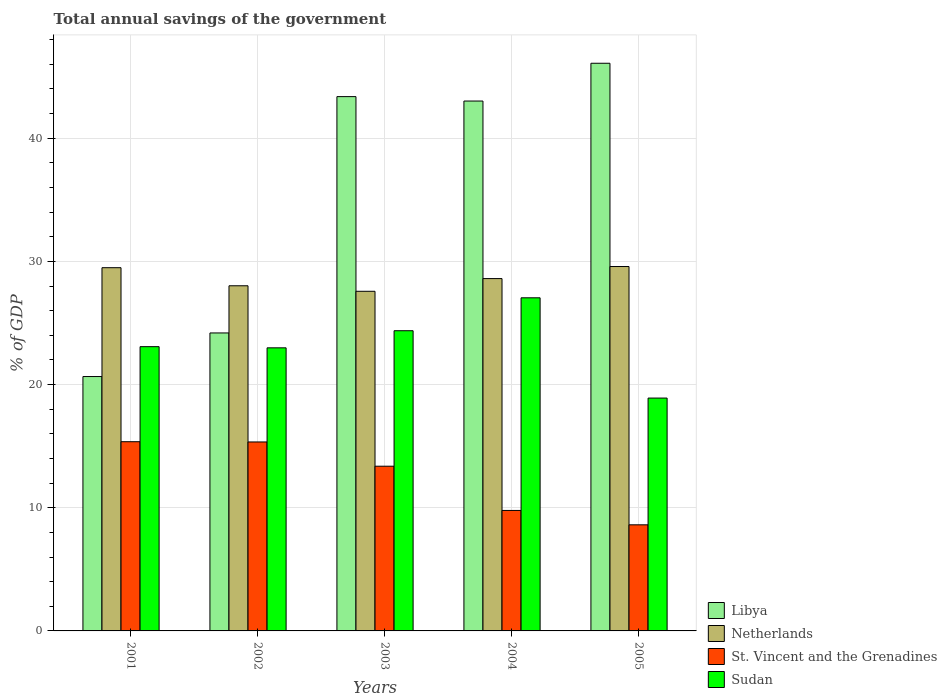How many different coloured bars are there?
Your answer should be compact. 4. Are the number of bars per tick equal to the number of legend labels?
Offer a terse response. Yes. Are the number of bars on each tick of the X-axis equal?
Offer a terse response. Yes. How many bars are there on the 1st tick from the left?
Make the answer very short. 4. What is the label of the 3rd group of bars from the left?
Your answer should be compact. 2003. In how many cases, is the number of bars for a given year not equal to the number of legend labels?
Ensure brevity in your answer.  0. What is the total annual savings of the government in Libya in 2005?
Ensure brevity in your answer.  46.09. Across all years, what is the maximum total annual savings of the government in St. Vincent and the Grenadines?
Your answer should be compact. 15.36. Across all years, what is the minimum total annual savings of the government in Netherlands?
Make the answer very short. 27.58. In which year was the total annual savings of the government in St. Vincent and the Grenadines maximum?
Your answer should be very brief. 2001. What is the total total annual savings of the government in Libya in the graph?
Your answer should be compact. 177.34. What is the difference between the total annual savings of the government in Netherlands in 2002 and that in 2003?
Provide a succinct answer. 0.45. What is the difference between the total annual savings of the government in Libya in 2003 and the total annual savings of the government in Sudan in 2001?
Your response must be concise. 20.3. What is the average total annual savings of the government in Libya per year?
Offer a terse response. 35.47. In the year 2002, what is the difference between the total annual savings of the government in St. Vincent and the Grenadines and total annual savings of the government in Netherlands?
Give a very brief answer. -12.68. What is the ratio of the total annual savings of the government in St. Vincent and the Grenadines in 2001 to that in 2002?
Provide a succinct answer. 1. Is the difference between the total annual savings of the government in St. Vincent and the Grenadines in 2002 and 2005 greater than the difference between the total annual savings of the government in Netherlands in 2002 and 2005?
Your answer should be very brief. Yes. What is the difference between the highest and the second highest total annual savings of the government in Sudan?
Make the answer very short. 2.67. What is the difference between the highest and the lowest total annual savings of the government in Libya?
Make the answer very short. 25.44. In how many years, is the total annual savings of the government in St. Vincent and the Grenadines greater than the average total annual savings of the government in St. Vincent and the Grenadines taken over all years?
Your answer should be very brief. 3. Is the sum of the total annual savings of the government in St. Vincent and the Grenadines in 2002 and 2005 greater than the maximum total annual savings of the government in Libya across all years?
Make the answer very short. No. What does the 2nd bar from the left in 2005 represents?
Your answer should be compact. Netherlands. What does the 1st bar from the right in 2002 represents?
Make the answer very short. Sudan. How many bars are there?
Your answer should be compact. 20. Where does the legend appear in the graph?
Ensure brevity in your answer.  Bottom right. How are the legend labels stacked?
Ensure brevity in your answer.  Vertical. What is the title of the graph?
Your response must be concise. Total annual savings of the government. What is the label or title of the Y-axis?
Your response must be concise. % of GDP. What is the % of GDP in Libya in 2001?
Your answer should be compact. 20.65. What is the % of GDP in Netherlands in 2001?
Give a very brief answer. 29.49. What is the % of GDP in St. Vincent and the Grenadines in 2001?
Provide a succinct answer. 15.36. What is the % of GDP of Sudan in 2001?
Your response must be concise. 23.08. What is the % of GDP of Libya in 2002?
Give a very brief answer. 24.19. What is the % of GDP in Netherlands in 2002?
Give a very brief answer. 28.02. What is the % of GDP of St. Vincent and the Grenadines in 2002?
Offer a terse response. 15.34. What is the % of GDP in Sudan in 2002?
Give a very brief answer. 22.98. What is the % of GDP of Libya in 2003?
Provide a succinct answer. 43.38. What is the % of GDP of Netherlands in 2003?
Provide a succinct answer. 27.58. What is the % of GDP of St. Vincent and the Grenadines in 2003?
Provide a succinct answer. 13.37. What is the % of GDP in Sudan in 2003?
Ensure brevity in your answer.  24.37. What is the % of GDP of Libya in 2004?
Provide a short and direct response. 43.02. What is the % of GDP in Netherlands in 2004?
Your response must be concise. 28.61. What is the % of GDP in St. Vincent and the Grenadines in 2004?
Offer a very short reply. 9.78. What is the % of GDP in Sudan in 2004?
Give a very brief answer. 27.05. What is the % of GDP in Libya in 2005?
Give a very brief answer. 46.09. What is the % of GDP in Netherlands in 2005?
Keep it short and to the point. 29.59. What is the % of GDP in St. Vincent and the Grenadines in 2005?
Your answer should be very brief. 8.61. What is the % of GDP of Sudan in 2005?
Give a very brief answer. 18.9. Across all years, what is the maximum % of GDP in Libya?
Keep it short and to the point. 46.09. Across all years, what is the maximum % of GDP in Netherlands?
Offer a very short reply. 29.59. Across all years, what is the maximum % of GDP of St. Vincent and the Grenadines?
Provide a short and direct response. 15.36. Across all years, what is the maximum % of GDP of Sudan?
Make the answer very short. 27.05. Across all years, what is the minimum % of GDP of Libya?
Your response must be concise. 20.65. Across all years, what is the minimum % of GDP of Netherlands?
Provide a short and direct response. 27.58. Across all years, what is the minimum % of GDP in St. Vincent and the Grenadines?
Offer a very short reply. 8.61. Across all years, what is the minimum % of GDP in Sudan?
Your response must be concise. 18.9. What is the total % of GDP of Libya in the graph?
Keep it short and to the point. 177.34. What is the total % of GDP in Netherlands in the graph?
Offer a very short reply. 143.28. What is the total % of GDP in St. Vincent and the Grenadines in the graph?
Offer a very short reply. 62.47. What is the total % of GDP of Sudan in the graph?
Offer a terse response. 116.39. What is the difference between the % of GDP in Libya in 2001 and that in 2002?
Provide a succinct answer. -3.54. What is the difference between the % of GDP in Netherlands in 2001 and that in 2002?
Your response must be concise. 1.47. What is the difference between the % of GDP of St. Vincent and the Grenadines in 2001 and that in 2002?
Make the answer very short. 0.02. What is the difference between the % of GDP of Sudan in 2001 and that in 2002?
Your answer should be very brief. 0.09. What is the difference between the % of GDP in Libya in 2001 and that in 2003?
Give a very brief answer. -22.73. What is the difference between the % of GDP in Netherlands in 2001 and that in 2003?
Your answer should be very brief. 1.92. What is the difference between the % of GDP of St. Vincent and the Grenadines in 2001 and that in 2003?
Provide a succinct answer. 1.99. What is the difference between the % of GDP in Sudan in 2001 and that in 2003?
Your answer should be very brief. -1.29. What is the difference between the % of GDP in Libya in 2001 and that in 2004?
Offer a terse response. -22.37. What is the difference between the % of GDP of Netherlands in 2001 and that in 2004?
Your answer should be compact. 0.88. What is the difference between the % of GDP of St. Vincent and the Grenadines in 2001 and that in 2004?
Make the answer very short. 5.58. What is the difference between the % of GDP of Sudan in 2001 and that in 2004?
Provide a short and direct response. -3.97. What is the difference between the % of GDP of Libya in 2001 and that in 2005?
Your answer should be compact. -25.44. What is the difference between the % of GDP in Netherlands in 2001 and that in 2005?
Your response must be concise. -0.1. What is the difference between the % of GDP in St. Vincent and the Grenadines in 2001 and that in 2005?
Your answer should be compact. 6.75. What is the difference between the % of GDP in Sudan in 2001 and that in 2005?
Provide a succinct answer. 4.17. What is the difference between the % of GDP of Libya in 2002 and that in 2003?
Your answer should be very brief. -19.19. What is the difference between the % of GDP of Netherlands in 2002 and that in 2003?
Offer a very short reply. 0.45. What is the difference between the % of GDP of St. Vincent and the Grenadines in 2002 and that in 2003?
Your answer should be compact. 1.97. What is the difference between the % of GDP in Sudan in 2002 and that in 2003?
Your answer should be very brief. -1.39. What is the difference between the % of GDP in Libya in 2002 and that in 2004?
Keep it short and to the point. -18.83. What is the difference between the % of GDP of Netherlands in 2002 and that in 2004?
Give a very brief answer. -0.58. What is the difference between the % of GDP in St. Vincent and the Grenadines in 2002 and that in 2004?
Provide a short and direct response. 5.56. What is the difference between the % of GDP in Sudan in 2002 and that in 2004?
Offer a terse response. -4.06. What is the difference between the % of GDP of Libya in 2002 and that in 2005?
Give a very brief answer. -21.9. What is the difference between the % of GDP of Netherlands in 2002 and that in 2005?
Offer a terse response. -1.56. What is the difference between the % of GDP of St. Vincent and the Grenadines in 2002 and that in 2005?
Ensure brevity in your answer.  6.73. What is the difference between the % of GDP of Sudan in 2002 and that in 2005?
Your answer should be compact. 4.08. What is the difference between the % of GDP of Libya in 2003 and that in 2004?
Provide a succinct answer. 0.36. What is the difference between the % of GDP of Netherlands in 2003 and that in 2004?
Ensure brevity in your answer.  -1.03. What is the difference between the % of GDP in St. Vincent and the Grenadines in 2003 and that in 2004?
Provide a succinct answer. 3.59. What is the difference between the % of GDP in Sudan in 2003 and that in 2004?
Keep it short and to the point. -2.67. What is the difference between the % of GDP of Libya in 2003 and that in 2005?
Give a very brief answer. -2.71. What is the difference between the % of GDP of Netherlands in 2003 and that in 2005?
Your response must be concise. -2.01. What is the difference between the % of GDP in St. Vincent and the Grenadines in 2003 and that in 2005?
Provide a succinct answer. 4.76. What is the difference between the % of GDP in Sudan in 2003 and that in 2005?
Make the answer very short. 5.47. What is the difference between the % of GDP of Libya in 2004 and that in 2005?
Your answer should be very brief. -3.07. What is the difference between the % of GDP in Netherlands in 2004 and that in 2005?
Provide a short and direct response. -0.98. What is the difference between the % of GDP of St. Vincent and the Grenadines in 2004 and that in 2005?
Provide a short and direct response. 1.17. What is the difference between the % of GDP in Sudan in 2004 and that in 2005?
Your answer should be compact. 8.14. What is the difference between the % of GDP of Libya in 2001 and the % of GDP of Netherlands in 2002?
Your answer should be compact. -7.37. What is the difference between the % of GDP in Libya in 2001 and the % of GDP in St. Vincent and the Grenadines in 2002?
Make the answer very short. 5.31. What is the difference between the % of GDP in Libya in 2001 and the % of GDP in Sudan in 2002?
Provide a short and direct response. -2.33. What is the difference between the % of GDP in Netherlands in 2001 and the % of GDP in St. Vincent and the Grenadines in 2002?
Offer a terse response. 14.15. What is the difference between the % of GDP of Netherlands in 2001 and the % of GDP of Sudan in 2002?
Make the answer very short. 6.51. What is the difference between the % of GDP in St. Vincent and the Grenadines in 2001 and the % of GDP in Sudan in 2002?
Offer a very short reply. -7.62. What is the difference between the % of GDP in Libya in 2001 and the % of GDP in Netherlands in 2003?
Your answer should be compact. -6.92. What is the difference between the % of GDP in Libya in 2001 and the % of GDP in St. Vincent and the Grenadines in 2003?
Make the answer very short. 7.28. What is the difference between the % of GDP in Libya in 2001 and the % of GDP in Sudan in 2003?
Provide a succinct answer. -3.72. What is the difference between the % of GDP of Netherlands in 2001 and the % of GDP of St. Vincent and the Grenadines in 2003?
Keep it short and to the point. 16.12. What is the difference between the % of GDP in Netherlands in 2001 and the % of GDP in Sudan in 2003?
Make the answer very short. 5.12. What is the difference between the % of GDP of St. Vincent and the Grenadines in 2001 and the % of GDP of Sudan in 2003?
Offer a terse response. -9.01. What is the difference between the % of GDP of Libya in 2001 and the % of GDP of Netherlands in 2004?
Ensure brevity in your answer.  -7.95. What is the difference between the % of GDP of Libya in 2001 and the % of GDP of St. Vincent and the Grenadines in 2004?
Keep it short and to the point. 10.87. What is the difference between the % of GDP of Libya in 2001 and the % of GDP of Sudan in 2004?
Your answer should be compact. -6.39. What is the difference between the % of GDP of Netherlands in 2001 and the % of GDP of St. Vincent and the Grenadines in 2004?
Provide a short and direct response. 19.71. What is the difference between the % of GDP of Netherlands in 2001 and the % of GDP of Sudan in 2004?
Provide a short and direct response. 2.44. What is the difference between the % of GDP of St. Vincent and the Grenadines in 2001 and the % of GDP of Sudan in 2004?
Offer a terse response. -11.68. What is the difference between the % of GDP of Libya in 2001 and the % of GDP of Netherlands in 2005?
Provide a short and direct response. -8.93. What is the difference between the % of GDP of Libya in 2001 and the % of GDP of St. Vincent and the Grenadines in 2005?
Your response must be concise. 12.04. What is the difference between the % of GDP of Libya in 2001 and the % of GDP of Sudan in 2005?
Keep it short and to the point. 1.75. What is the difference between the % of GDP in Netherlands in 2001 and the % of GDP in St. Vincent and the Grenadines in 2005?
Your answer should be compact. 20.88. What is the difference between the % of GDP of Netherlands in 2001 and the % of GDP of Sudan in 2005?
Ensure brevity in your answer.  10.59. What is the difference between the % of GDP in St. Vincent and the Grenadines in 2001 and the % of GDP in Sudan in 2005?
Your answer should be very brief. -3.54. What is the difference between the % of GDP in Libya in 2002 and the % of GDP in Netherlands in 2003?
Make the answer very short. -3.38. What is the difference between the % of GDP of Libya in 2002 and the % of GDP of St. Vincent and the Grenadines in 2003?
Provide a short and direct response. 10.82. What is the difference between the % of GDP in Libya in 2002 and the % of GDP in Sudan in 2003?
Your answer should be very brief. -0.18. What is the difference between the % of GDP of Netherlands in 2002 and the % of GDP of St. Vincent and the Grenadines in 2003?
Provide a short and direct response. 14.65. What is the difference between the % of GDP of Netherlands in 2002 and the % of GDP of Sudan in 2003?
Offer a very short reply. 3.65. What is the difference between the % of GDP in St. Vincent and the Grenadines in 2002 and the % of GDP in Sudan in 2003?
Your answer should be very brief. -9.03. What is the difference between the % of GDP in Libya in 2002 and the % of GDP in Netherlands in 2004?
Your answer should be compact. -4.41. What is the difference between the % of GDP in Libya in 2002 and the % of GDP in St. Vincent and the Grenadines in 2004?
Your answer should be compact. 14.41. What is the difference between the % of GDP in Libya in 2002 and the % of GDP in Sudan in 2004?
Your answer should be very brief. -2.85. What is the difference between the % of GDP in Netherlands in 2002 and the % of GDP in St. Vincent and the Grenadines in 2004?
Your response must be concise. 18.24. What is the difference between the % of GDP in Netherlands in 2002 and the % of GDP in Sudan in 2004?
Ensure brevity in your answer.  0.98. What is the difference between the % of GDP in St. Vincent and the Grenadines in 2002 and the % of GDP in Sudan in 2004?
Your answer should be compact. -11.7. What is the difference between the % of GDP in Libya in 2002 and the % of GDP in Netherlands in 2005?
Keep it short and to the point. -5.39. What is the difference between the % of GDP in Libya in 2002 and the % of GDP in St. Vincent and the Grenadines in 2005?
Ensure brevity in your answer.  15.58. What is the difference between the % of GDP of Libya in 2002 and the % of GDP of Sudan in 2005?
Give a very brief answer. 5.29. What is the difference between the % of GDP in Netherlands in 2002 and the % of GDP in St. Vincent and the Grenadines in 2005?
Ensure brevity in your answer.  19.41. What is the difference between the % of GDP of Netherlands in 2002 and the % of GDP of Sudan in 2005?
Provide a succinct answer. 9.12. What is the difference between the % of GDP in St. Vincent and the Grenadines in 2002 and the % of GDP in Sudan in 2005?
Provide a short and direct response. -3.56. What is the difference between the % of GDP in Libya in 2003 and the % of GDP in Netherlands in 2004?
Your answer should be compact. 14.77. What is the difference between the % of GDP in Libya in 2003 and the % of GDP in St. Vincent and the Grenadines in 2004?
Keep it short and to the point. 33.6. What is the difference between the % of GDP in Libya in 2003 and the % of GDP in Sudan in 2004?
Give a very brief answer. 16.33. What is the difference between the % of GDP of Netherlands in 2003 and the % of GDP of St. Vincent and the Grenadines in 2004?
Offer a very short reply. 17.79. What is the difference between the % of GDP of Netherlands in 2003 and the % of GDP of Sudan in 2004?
Provide a succinct answer. 0.53. What is the difference between the % of GDP in St. Vincent and the Grenadines in 2003 and the % of GDP in Sudan in 2004?
Your answer should be very brief. -13.67. What is the difference between the % of GDP in Libya in 2003 and the % of GDP in Netherlands in 2005?
Offer a terse response. 13.79. What is the difference between the % of GDP in Libya in 2003 and the % of GDP in St. Vincent and the Grenadines in 2005?
Your answer should be very brief. 34.77. What is the difference between the % of GDP of Libya in 2003 and the % of GDP of Sudan in 2005?
Keep it short and to the point. 24.48. What is the difference between the % of GDP in Netherlands in 2003 and the % of GDP in St. Vincent and the Grenadines in 2005?
Offer a terse response. 18.96. What is the difference between the % of GDP of Netherlands in 2003 and the % of GDP of Sudan in 2005?
Offer a terse response. 8.67. What is the difference between the % of GDP in St. Vincent and the Grenadines in 2003 and the % of GDP in Sudan in 2005?
Keep it short and to the point. -5.53. What is the difference between the % of GDP of Libya in 2004 and the % of GDP of Netherlands in 2005?
Offer a very short reply. 13.44. What is the difference between the % of GDP in Libya in 2004 and the % of GDP in St. Vincent and the Grenadines in 2005?
Offer a terse response. 34.41. What is the difference between the % of GDP in Libya in 2004 and the % of GDP in Sudan in 2005?
Keep it short and to the point. 24.12. What is the difference between the % of GDP of Netherlands in 2004 and the % of GDP of St. Vincent and the Grenadines in 2005?
Your response must be concise. 19.99. What is the difference between the % of GDP in Netherlands in 2004 and the % of GDP in Sudan in 2005?
Offer a very short reply. 9.7. What is the difference between the % of GDP of St. Vincent and the Grenadines in 2004 and the % of GDP of Sudan in 2005?
Keep it short and to the point. -9.12. What is the average % of GDP of Libya per year?
Offer a terse response. 35.47. What is the average % of GDP of Netherlands per year?
Offer a terse response. 28.66. What is the average % of GDP of St. Vincent and the Grenadines per year?
Your answer should be compact. 12.49. What is the average % of GDP of Sudan per year?
Your response must be concise. 23.28. In the year 2001, what is the difference between the % of GDP in Libya and % of GDP in Netherlands?
Your answer should be very brief. -8.84. In the year 2001, what is the difference between the % of GDP in Libya and % of GDP in St. Vincent and the Grenadines?
Make the answer very short. 5.29. In the year 2001, what is the difference between the % of GDP of Libya and % of GDP of Sudan?
Offer a terse response. -2.42. In the year 2001, what is the difference between the % of GDP in Netherlands and % of GDP in St. Vincent and the Grenadines?
Keep it short and to the point. 14.13. In the year 2001, what is the difference between the % of GDP in Netherlands and % of GDP in Sudan?
Your answer should be very brief. 6.41. In the year 2001, what is the difference between the % of GDP in St. Vincent and the Grenadines and % of GDP in Sudan?
Provide a short and direct response. -7.72. In the year 2002, what is the difference between the % of GDP of Libya and % of GDP of Netherlands?
Offer a terse response. -3.83. In the year 2002, what is the difference between the % of GDP of Libya and % of GDP of St. Vincent and the Grenadines?
Your answer should be very brief. 8.85. In the year 2002, what is the difference between the % of GDP of Libya and % of GDP of Sudan?
Your answer should be very brief. 1.21. In the year 2002, what is the difference between the % of GDP of Netherlands and % of GDP of St. Vincent and the Grenadines?
Keep it short and to the point. 12.68. In the year 2002, what is the difference between the % of GDP in Netherlands and % of GDP in Sudan?
Keep it short and to the point. 5.04. In the year 2002, what is the difference between the % of GDP in St. Vincent and the Grenadines and % of GDP in Sudan?
Your answer should be very brief. -7.64. In the year 2003, what is the difference between the % of GDP of Libya and % of GDP of Netherlands?
Provide a short and direct response. 15.81. In the year 2003, what is the difference between the % of GDP of Libya and % of GDP of St. Vincent and the Grenadines?
Provide a short and direct response. 30.01. In the year 2003, what is the difference between the % of GDP of Libya and % of GDP of Sudan?
Offer a very short reply. 19.01. In the year 2003, what is the difference between the % of GDP of Netherlands and % of GDP of St. Vincent and the Grenadines?
Ensure brevity in your answer.  14.2. In the year 2003, what is the difference between the % of GDP of Netherlands and % of GDP of Sudan?
Provide a short and direct response. 3.2. In the year 2003, what is the difference between the % of GDP of St. Vincent and the Grenadines and % of GDP of Sudan?
Provide a succinct answer. -11. In the year 2004, what is the difference between the % of GDP of Libya and % of GDP of Netherlands?
Offer a terse response. 14.42. In the year 2004, what is the difference between the % of GDP in Libya and % of GDP in St. Vincent and the Grenadines?
Give a very brief answer. 33.24. In the year 2004, what is the difference between the % of GDP of Libya and % of GDP of Sudan?
Your answer should be very brief. 15.98. In the year 2004, what is the difference between the % of GDP in Netherlands and % of GDP in St. Vincent and the Grenadines?
Your answer should be compact. 18.82. In the year 2004, what is the difference between the % of GDP in Netherlands and % of GDP in Sudan?
Offer a terse response. 1.56. In the year 2004, what is the difference between the % of GDP in St. Vincent and the Grenadines and % of GDP in Sudan?
Provide a short and direct response. -17.26. In the year 2005, what is the difference between the % of GDP of Libya and % of GDP of Netherlands?
Offer a terse response. 16.5. In the year 2005, what is the difference between the % of GDP in Libya and % of GDP in St. Vincent and the Grenadines?
Your answer should be very brief. 37.47. In the year 2005, what is the difference between the % of GDP of Libya and % of GDP of Sudan?
Your answer should be compact. 27.18. In the year 2005, what is the difference between the % of GDP in Netherlands and % of GDP in St. Vincent and the Grenadines?
Provide a succinct answer. 20.97. In the year 2005, what is the difference between the % of GDP in Netherlands and % of GDP in Sudan?
Give a very brief answer. 10.68. In the year 2005, what is the difference between the % of GDP in St. Vincent and the Grenadines and % of GDP in Sudan?
Ensure brevity in your answer.  -10.29. What is the ratio of the % of GDP in Libya in 2001 to that in 2002?
Make the answer very short. 0.85. What is the ratio of the % of GDP of Netherlands in 2001 to that in 2002?
Your answer should be compact. 1.05. What is the ratio of the % of GDP of St. Vincent and the Grenadines in 2001 to that in 2002?
Provide a short and direct response. 1. What is the ratio of the % of GDP in Libya in 2001 to that in 2003?
Make the answer very short. 0.48. What is the ratio of the % of GDP of Netherlands in 2001 to that in 2003?
Provide a succinct answer. 1.07. What is the ratio of the % of GDP in St. Vincent and the Grenadines in 2001 to that in 2003?
Offer a very short reply. 1.15. What is the ratio of the % of GDP of Sudan in 2001 to that in 2003?
Your response must be concise. 0.95. What is the ratio of the % of GDP in Libya in 2001 to that in 2004?
Ensure brevity in your answer.  0.48. What is the ratio of the % of GDP of Netherlands in 2001 to that in 2004?
Provide a short and direct response. 1.03. What is the ratio of the % of GDP of St. Vincent and the Grenadines in 2001 to that in 2004?
Make the answer very short. 1.57. What is the ratio of the % of GDP in Sudan in 2001 to that in 2004?
Give a very brief answer. 0.85. What is the ratio of the % of GDP in Libya in 2001 to that in 2005?
Make the answer very short. 0.45. What is the ratio of the % of GDP in St. Vincent and the Grenadines in 2001 to that in 2005?
Your answer should be very brief. 1.78. What is the ratio of the % of GDP of Sudan in 2001 to that in 2005?
Offer a very short reply. 1.22. What is the ratio of the % of GDP in Libya in 2002 to that in 2003?
Offer a terse response. 0.56. What is the ratio of the % of GDP in Netherlands in 2002 to that in 2003?
Offer a terse response. 1.02. What is the ratio of the % of GDP of St. Vincent and the Grenadines in 2002 to that in 2003?
Offer a terse response. 1.15. What is the ratio of the % of GDP of Sudan in 2002 to that in 2003?
Give a very brief answer. 0.94. What is the ratio of the % of GDP of Libya in 2002 to that in 2004?
Your answer should be very brief. 0.56. What is the ratio of the % of GDP in Netherlands in 2002 to that in 2004?
Your answer should be compact. 0.98. What is the ratio of the % of GDP of St. Vincent and the Grenadines in 2002 to that in 2004?
Your answer should be very brief. 1.57. What is the ratio of the % of GDP in Sudan in 2002 to that in 2004?
Give a very brief answer. 0.85. What is the ratio of the % of GDP in Libya in 2002 to that in 2005?
Provide a succinct answer. 0.52. What is the ratio of the % of GDP of Netherlands in 2002 to that in 2005?
Offer a very short reply. 0.95. What is the ratio of the % of GDP in St. Vincent and the Grenadines in 2002 to that in 2005?
Make the answer very short. 1.78. What is the ratio of the % of GDP of Sudan in 2002 to that in 2005?
Make the answer very short. 1.22. What is the ratio of the % of GDP of Libya in 2003 to that in 2004?
Give a very brief answer. 1.01. What is the ratio of the % of GDP in Netherlands in 2003 to that in 2004?
Provide a succinct answer. 0.96. What is the ratio of the % of GDP of St. Vincent and the Grenadines in 2003 to that in 2004?
Your answer should be very brief. 1.37. What is the ratio of the % of GDP in Sudan in 2003 to that in 2004?
Provide a short and direct response. 0.9. What is the ratio of the % of GDP of Netherlands in 2003 to that in 2005?
Provide a short and direct response. 0.93. What is the ratio of the % of GDP of St. Vincent and the Grenadines in 2003 to that in 2005?
Ensure brevity in your answer.  1.55. What is the ratio of the % of GDP of Sudan in 2003 to that in 2005?
Your response must be concise. 1.29. What is the ratio of the % of GDP in Libya in 2004 to that in 2005?
Ensure brevity in your answer.  0.93. What is the ratio of the % of GDP in Netherlands in 2004 to that in 2005?
Your response must be concise. 0.97. What is the ratio of the % of GDP in St. Vincent and the Grenadines in 2004 to that in 2005?
Offer a very short reply. 1.14. What is the ratio of the % of GDP in Sudan in 2004 to that in 2005?
Your answer should be compact. 1.43. What is the difference between the highest and the second highest % of GDP of Libya?
Provide a short and direct response. 2.71. What is the difference between the highest and the second highest % of GDP of Netherlands?
Provide a succinct answer. 0.1. What is the difference between the highest and the second highest % of GDP of St. Vincent and the Grenadines?
Provide a short and direct response. 0.02. What is the difference between the highest and the second highest % of GDP in Sudan?
Offer a very short reply. 2.67. What is the difference between the highest and the lowest % of GDP of Libya?
Your answer should be compact. 25.44. What is the difference between the highest and the lowest % of GDP of Netherlands?
Offer a terse response. 2.01. What is the difference between the highest and the lowest % of GDP in St. Vincent and the Grenadines?
Offer a terse response. 6.75. What is the difference between the highest and the lowest % of GDP of Sudan?
Offer a very short reply. 8.14. 